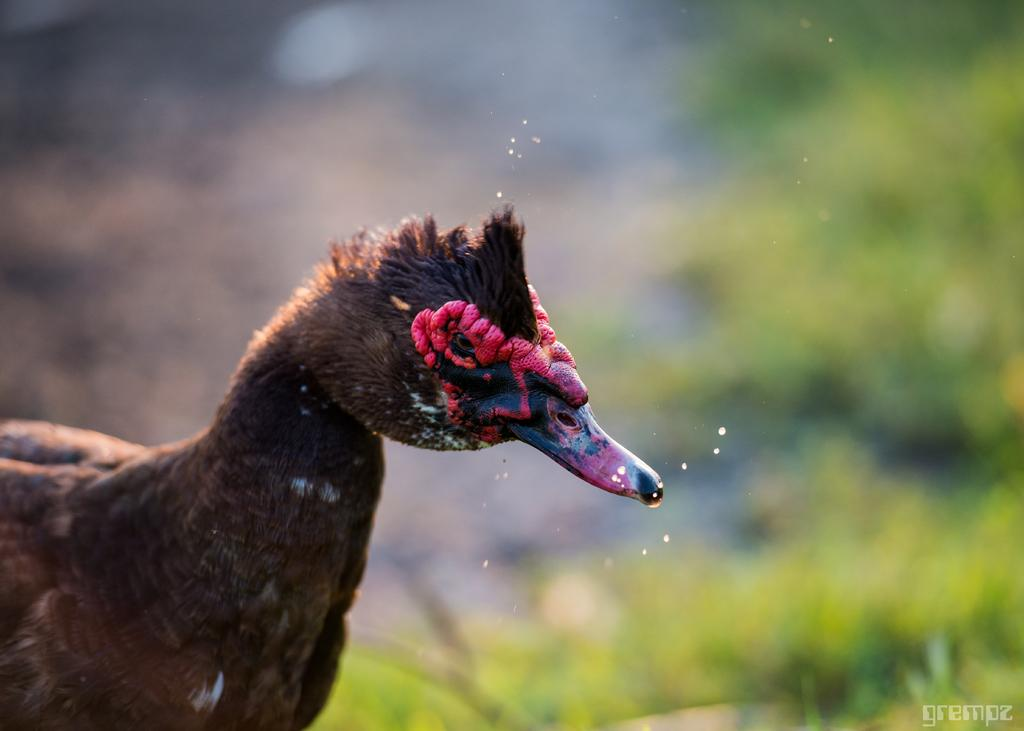What animal is in the foreground of the image? There is a duck in the foreground of the image. Can you describe the background of the image? The background of the image is blurred. What is the price of the fish in the image? There is no fish present in the image, so it is not possible to determine the price. 